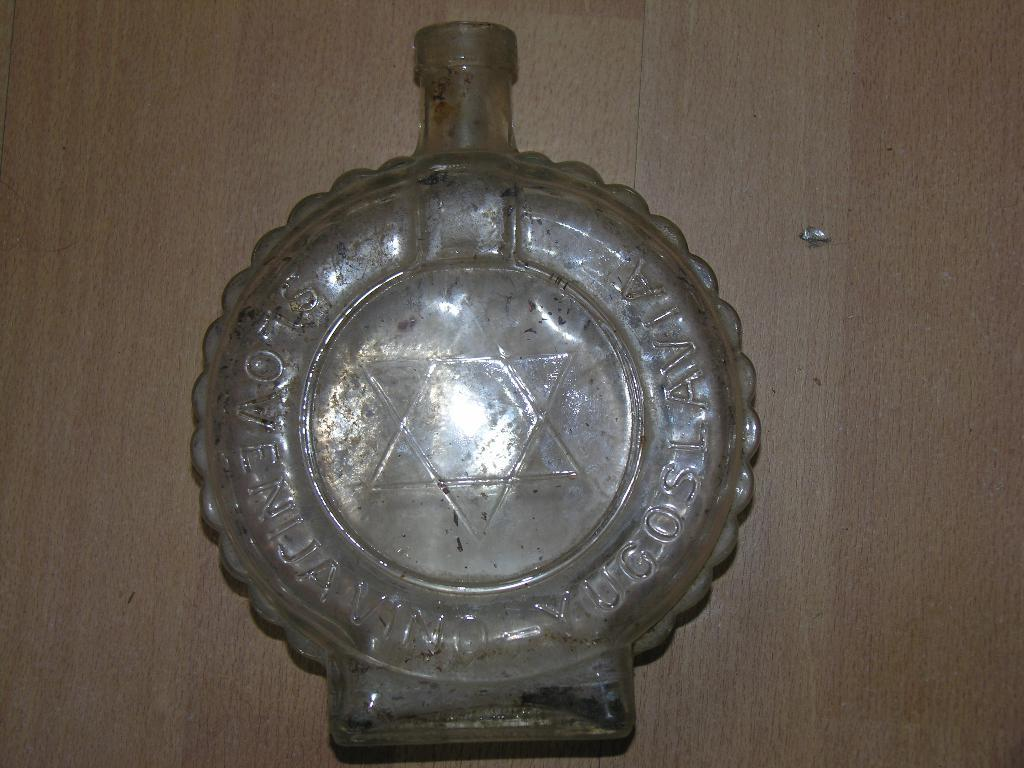What object in the image has a star design on it? The glass bottle in the image has a star design on it. Can you describe the appearance of the glass bottle? The glass bottle has a star design on it. What type of plant can be seen growing in the pot in the image? There is no pot or plant present in the image; it only features a glass bottle with a star design. 